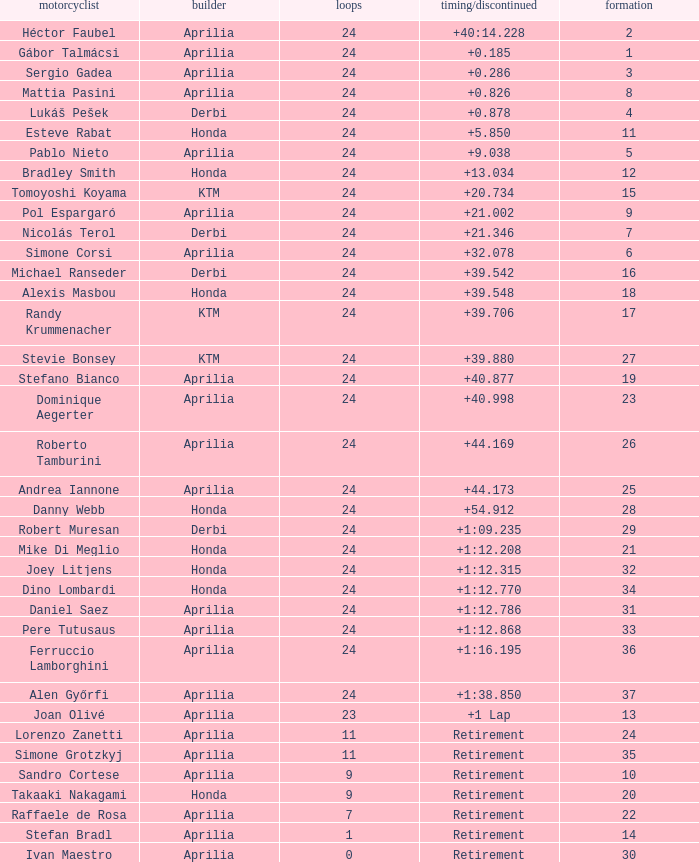How many grids correspond to more than 24 laps? None. 